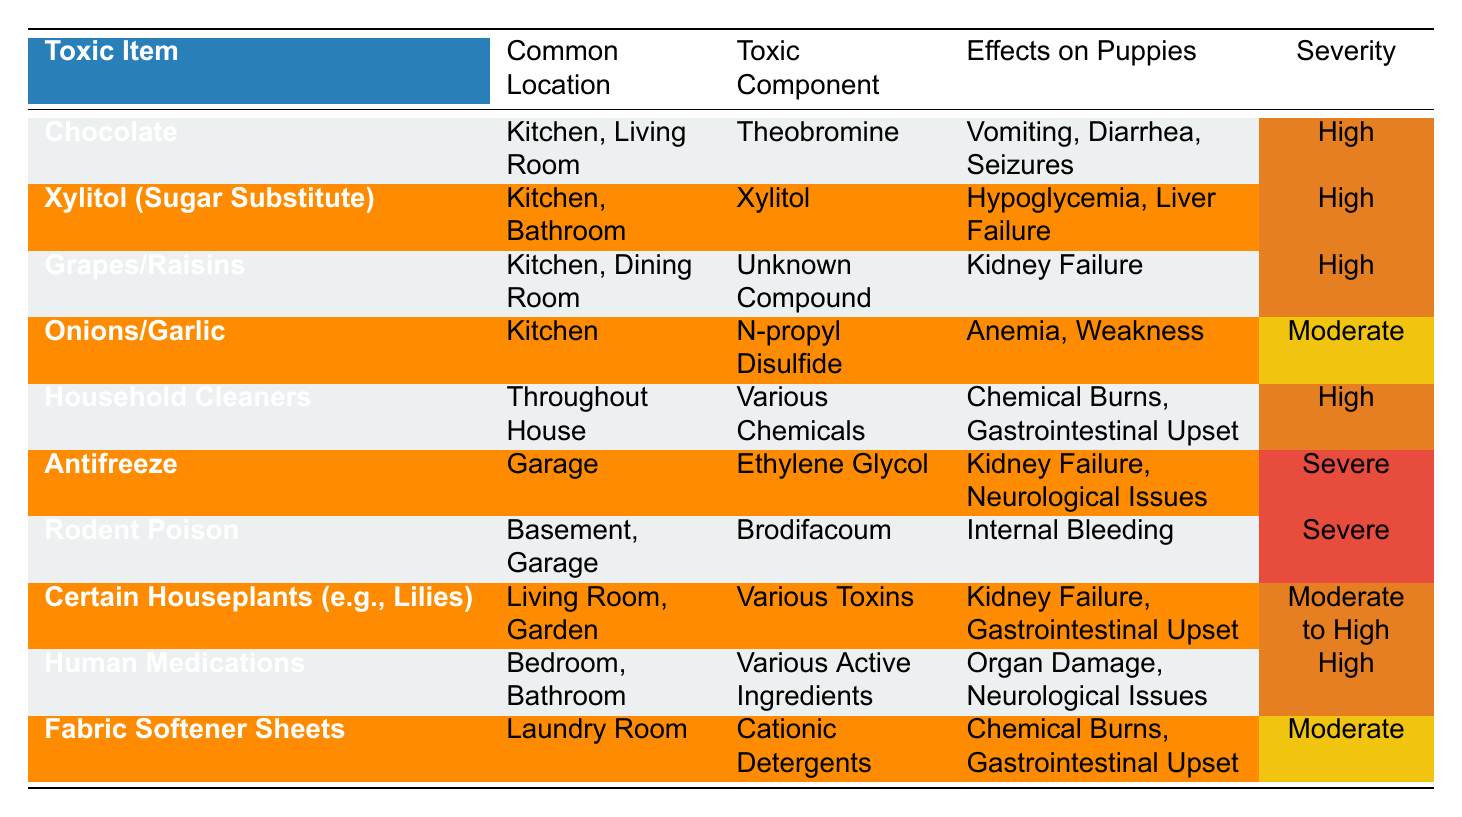What are the effects of chocolate on puppies? The table shows that chocolate causes vomiting, diarrhea, and seizures in puppies.
Answer: Vomiting, diarrhea, seizures Which item has the highest severity rating? The items with the highest severity rating are antifreeze and rodent poison, both marked as severe.
Answer: Antifreeze and rodent poison Is Xylitol found in kitchens? Yes, the table indicates that Xylitol is commonly found in the kitchen and bathroom.
Answer: Yes How many toxic items have a severity of "High"? There are six items labeled with a severity of "High": chocolate, Xylitol, grapes/raisins, household cleaners, human medications, and certain houseplants.
Answer: Six What toxic item is associated with kidney failure? The table lists several items related to kidney failure: grapes/raisins, antifreeze, and certain houseplants.
Answer: Grapes/raisins, antifreeze, certain houseplants Which common location has the most toxic items listed? The kitchen is mentioned as the location for chocolate, Xylitol, grapes/raisins, onions/garlic, and household cleaners, totaling five items.
Answer: Kitchen Are there more items causing gastrointestinal upset than those causing liver failure? Yes, three items (household cleaners, fabric softener sheets, and chocolate) cause gastrointestinal upset compared to only one item (Xylitol) that causes liver failure.
Answer: Yes What is the common component found in antifreeze? According to the table, the toxic component found in antifreeze is ethylene glycol.
Answer: Ethylene glycol Which item listed has a moderate severity rating? Onions/garlic and fabric softener sheets have a moderate severity rating according to the table.
Answer: Onions/garlic, fabric softener sheets How many items are found in the living room? The living room has three items: chocolate, certain houseplants, and household cleaners listed in common locations.
Answer: Three 